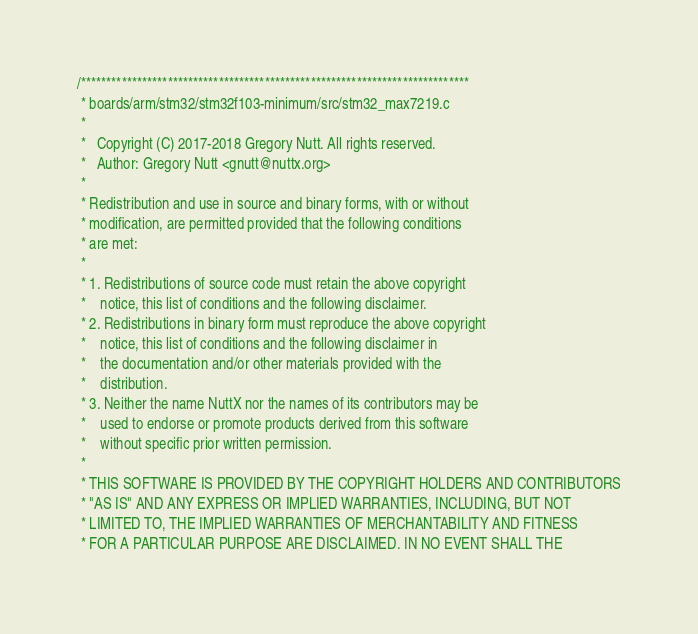Convert code to text. <code><loc_0><loc_0><loc_500><loc_500><_C_>/****************************************************************************
 * boards/arm/stm32/stm32f103-minimum/src/stm32_max7219.c
 *
 *   Copyright (C) 2017-2018 Gregory Nutt. All rights reserved.
 *   Author: Gregory Nutt <gnutt@nuttx.org>
 *
 * Redistribution and use in source and binary forms, with or without
 * modification, are permitted provided that the following conditions
 * are met:
 *
 * 1. Redistributions of source code must retain the above copyright
 *    notice, this list of conditions and the following disclaimer.
 * 2. Redistributions in binary form must reproduce the above copyright
 *    notice, this list of conditions and the following disclaimer in
 *    the documentation and/or other materials provided with the
 *    distribution.
 * 3. Neither the name NuttX nor the names of its contributors may be
 *    used to endorse or promote products derived from this software
 *    without specific prior written permission.
 *
 * THIS SOFTWARE IS PROVIDED BY THE COPYRIGHT HOLDERS AND CONTRIBUTORS
 * "AS IS" AND ANY EXPRESS OR IMPLIED WARRANTIES, INCLUDING, BUT NOT
 * LIMITED TO, THE IMPLIED WARRANTIES OF MERCHANTABILITY AND FITNESS
 * FOR A PARTICULAR PURPOSE ARE DISCLAIMED. IN NO EVENT SHALL THE</code> 